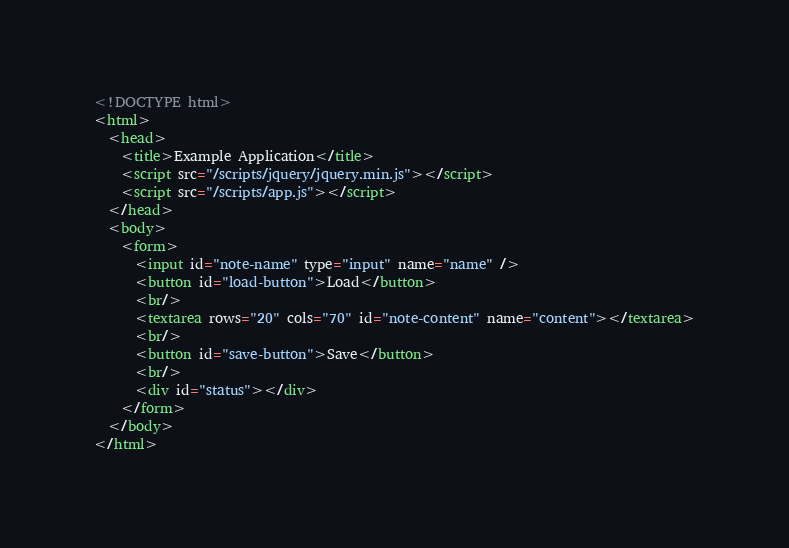Convert code to text. <code><loc_0><loc_0><loc_500><loc_500><_HTML_><!DOCTYPE html>
<html>
  <head>
    <title>Example Application</title>
    <script src="/scripts/jquery/jquery.min.js"></script>
    <script src="/scripts/app.js"></script>
  </head>
  <body>
    <form>
      <input id="note-name" type="input" name="name" />
      <button id="load-button">Load</button>
      <br/>
      <textarea rows="20" cols="70" id="note-content" name="content"></textarea>
      <br/>
      <button id="save-button">Save</button>
      <br/>
      <div id="status"></div>
    </form>
  </body>
</html>
</code> 